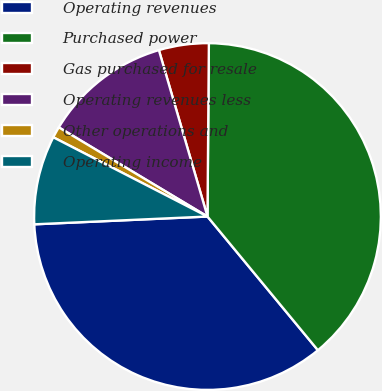<chart> <loc_0><loc_0><loc_500><loc_500><pie_chart><fcel>Operating revenues<fcel>Purchased power<fcel>Gas purchased for resale<fcel>Operating revenues less<fcel>Other operations and<fcel>Operating income<nl><fcel>35.27%<fcel>38.88%<fcel>4.65%<fcel>11.88%<fcel>1.04%<fcel>8.27%<nl></chart> 